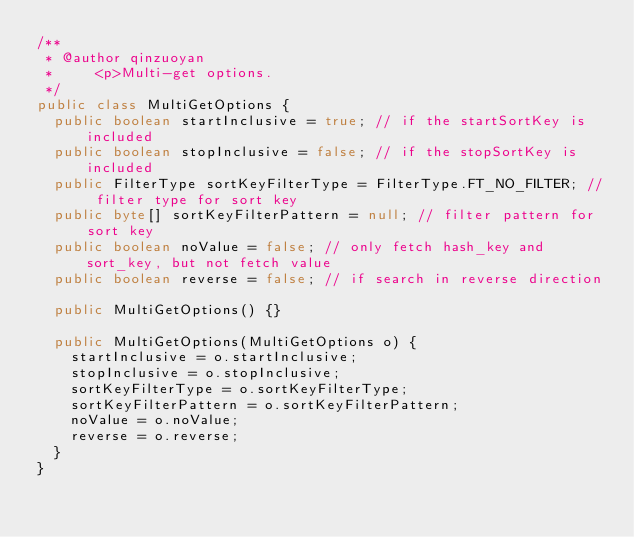Convert code to text. <code><loc_0><loc_0><loc_500><loc_500><_Java_>/**
 * @author qinzuoyan
 *     <p>Multi-get options.
 */
public class MultiGetOptions {
  public boolean startInclusive = true; // if the startSortKey is included
  public boolean stopInclusive = false; // if the stopSortKey is included
  public FilterType sortKeyFilterType = FilterType.FT_NO_FILTER; // filter type for sort key
  public byte[] sortKeyFilterPattern = null; // filter pattern for sort key
  public boolean noValue = false; // only fetch hash_key and sort_key, but not fetch value
  public boolean reverse = false; // if search in reverse direction

  public MultiGetOptions() {}

  public MultiGetOptions(MultiGetOptions o) {
    startInclusive = o.startInclusive;
    stopInclusive = o.stopInclusive;
    sortKeyFilterType = o.sortKeyFilterType;
    sortKeyFilterPattern = o.sortKeyFilterPattern;
    noValue = o.noValue;
    reverse = o.reverse;
  }
}
</code> 